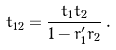Convert formula to latex. <formula><loc_0><loc_0><loc_500><loc_500>t _ { 1 2 } = \frac { t _ { 1 } t _ { 2 } } { 1 - r ^ { \prime } _ { 1 } r _ { 2 } } \, .</formula> 